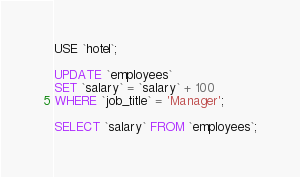<code> <loc_0><loc_0><loc_500><loc_500><_SQL_>USE `hotel`;

UPDATE `employees`
SET `salary` = `salary` + 100
WHERE `job_title` = 'Manager';

SELECT `salary` FROM `employees`;
</code> 